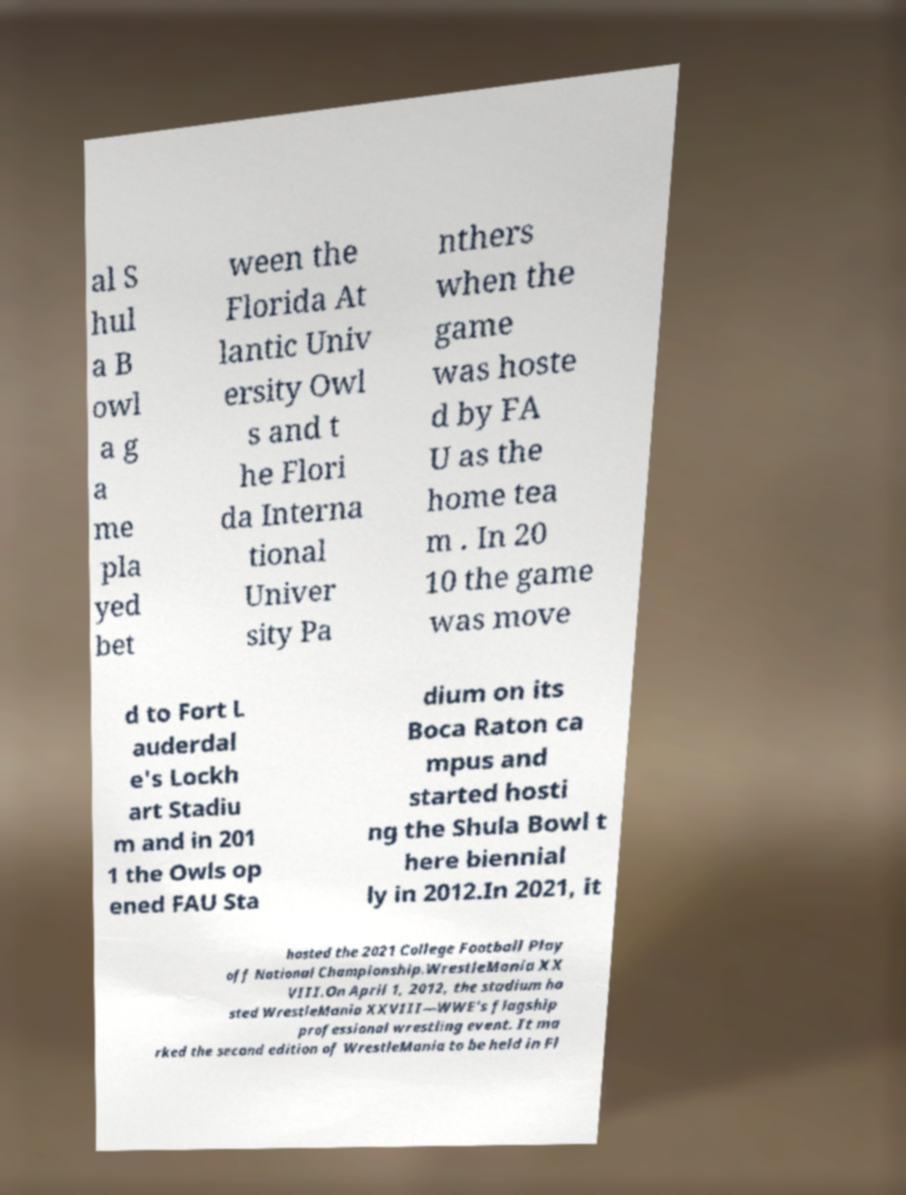Could you extract and type out the text from this image? al S hul a B owl a g a me pla yed bet ween the Florida At lantic Univ ersity Owl s and t he Flori da Interna tional Univer sity Pa nthers when the game was hoste d by FA U as the home tea m . In 20 10 the game was move d to Fort L auderdal e's Lockh art Stadiu m and in 201 1 the Owls op ened FAU Sta dium on its Boca Raton ca mpus and started hosti ng the Shula Bowl t here biennial ly in 2012.In 2021, it hosted the 2021 College Football Play off National Championship.WrestleMania XX VIII.On April 1, 2012, the stadium ho sted WrestleMania XXVIII—WWE's flagship professional wrestling event. It ma rked the second edition of WrestleMania to be held in Fl 